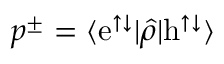Convert formula to latex. <formula><loc_0><loc_0><loc_500><loc_500>p ^ { \pm } = \langle e ^ { \uparrow \downarrow } | \hat { \rho } | h ^ { \uparrow \downarrow } \rangle</formula> 